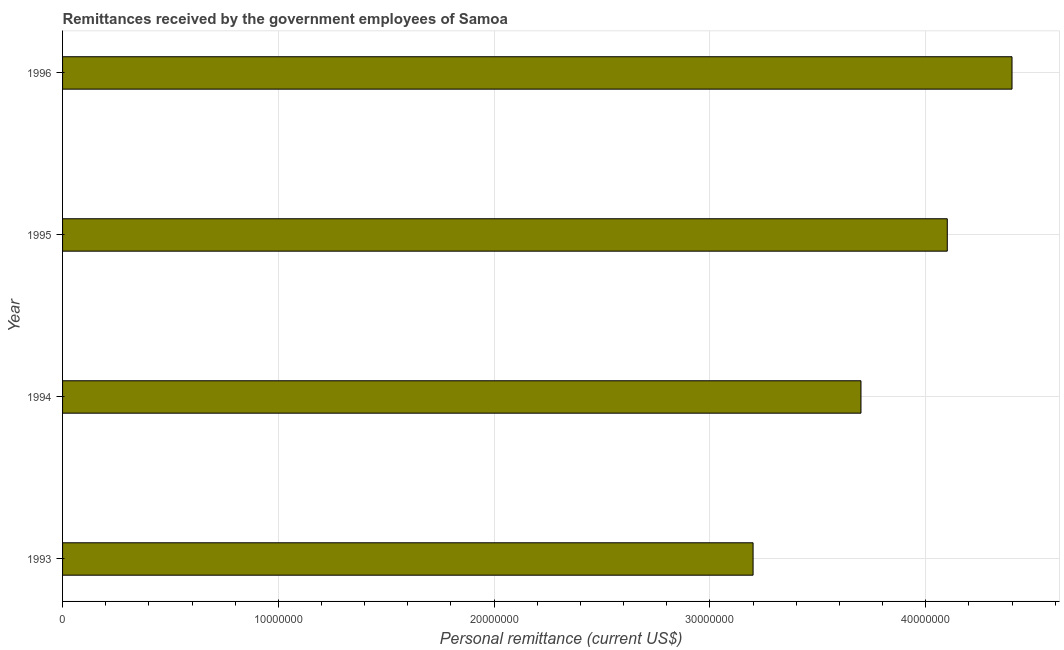What is the title of the graph?
Offer a very short reply. Remittances received by the government employees of Samoa. What is the label or title of the X-axis?
Make the answer very short. Personal remittance (current US$). What is the label or title of the Y-axis?
Keep it short and to the point. Year. What is the personal remittances in 1993?
Keep it short and to the point. 3.20e+07. Across all years, what is the maximum personal remittances?
Keep it short and to the point. 4.40e+07. Across all years, what is the minimum personal remittances?
Offer a very short reply. 3.20e+07. In which year was the personal remittances maximum?
Keep it short and to the point. 1996. In which year was the personal remittances minimum?
Your response must be concise. 1993. What is the sum of the personal remittances?
Your response must be concise. 1.54e+08. What is the average personal remittances per year?
Provide a short and direct response. 3.85e+07. What is the median personal remittances?
Ensure brevity in your answer.  3.90e+07. In how many years, is the personal remittances greater than 32000000 US$?
Your response must be concise. 3. What is the ratio of the personal remittances in 1993 to that in 1995?
Your answer should be compact. 0.78. Is the difference between the personal remittances in 1993 and 1996 greater than the difference between any two years?
Provide a succinct answer. Yes. In how many years, is the personal remittances greater than the average personal remittances taken over all years?
Offer a very short reply. 2. How many years are there in the graph?
Ensure brevity in your answer.  4. What is the difference between two consecutive major ticks on the X-axis?
Your answer should be very brief. 1.00e+07. What is the Personal remittance (current US$) in 1993?
Your response must be concise. 3.20e+07. What is the Personal remittance (current US$) of 1994?
Your answer should be very brief. 3.70e+07. What is the Personal remittance (current US$) in 1995?
Make the answer very short. 4.10e+07. What is the Personal remittance (current US$) in 1996?
Your answer should be very brief. 4.40e+07. What is the difference between the Personal remittance (current US$) in 1993 and 1994?
Your answer should be compact. -5.00e+06. What is the difference between the Personal remittance (current US$) in 1993 and 1995?
Your answer should be compact. -9.00e+06. What is the difference between the Personal remittance (current US$) in 1993 and 1996?
Provide a succinct answer. -1.20e+07. What is the difference between the Personal remittance (current US$) in 1994 and 1995?
Give a very brief answer. -4.00e+06. What is the difference between the Personal remittance (current US$) in 1994 and 1996?
Your answer should be compact. -7.00e+06. What is the ratio of the Personal remittance (current US$) in 1993 to that in 1994?
Offer a very short reply. 0.86. What is the ratio of the Personal remittance (current US$) in 1993 to that in 1995?
Your response must be concise. 0.78. What is the ratio of the Personal remittance (current US$) in 1993 to that in 1996?
Offer a terse response. 0.73. What is the ratio of the Personal remittance (current US$) in 1994 to that in 1995?
Your response must be concise. 0.9. What is the ratio of the Personal remittance (current US$) in 1994 to that in 1996?
Ensure brevity in your answer.  0.84. What is the ratio of the Personal remittance (current US$) in 1995 to that in 1996?
Keep it short and to the point. 0.93. 